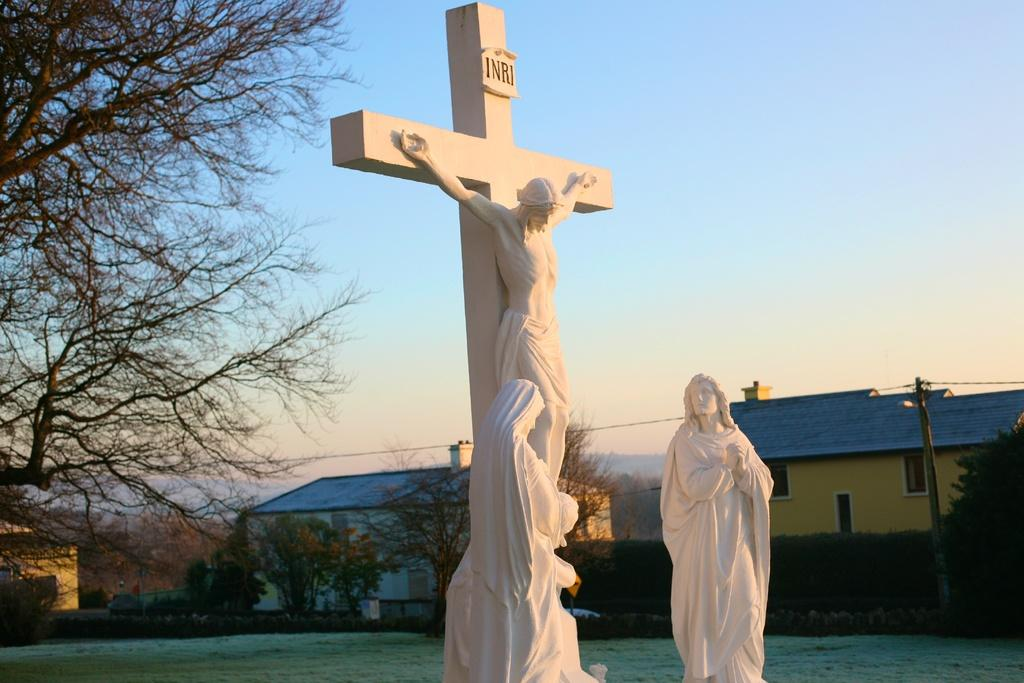Provide a one-sentence caption for the provided image. Two religious statues one of a cross and Jesus in it and with the words INRI on top the other one looking at the Jesus statue. 